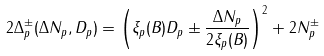<formula> <loc_0><loc_0><loc_500><loc_500>2 \Delta _ { p } ^ { \pm } ( { \Delta N _ { p } , D _ { p } } ) = \left ( \xi _ { p } ( B ) D _ { p } \pm \frac { \Delta N _ { p } } { 2 \xi _ { p } ( B ) } \right ) ^ { 2 } + 2 N _ { p } ^ { \pm }</formula> 